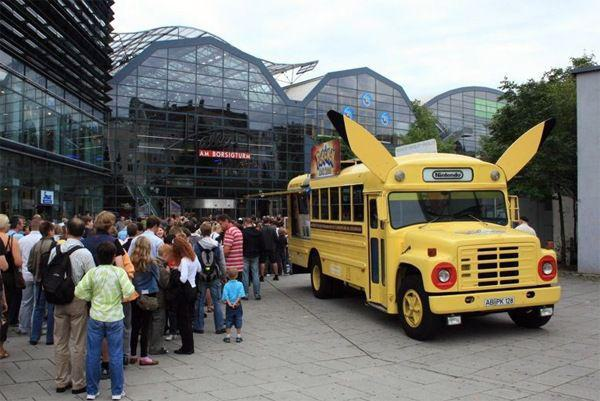How many unicorns would there be in the image after no additional unicorn was added in the image? Assuming there are no hidden unicorns within the image, the number of unicorns would remain the same after not adding any more — which is zero, as there are no unicorns visible in this particular scene. 